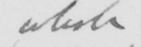What text is written in this handwritten line? whole 